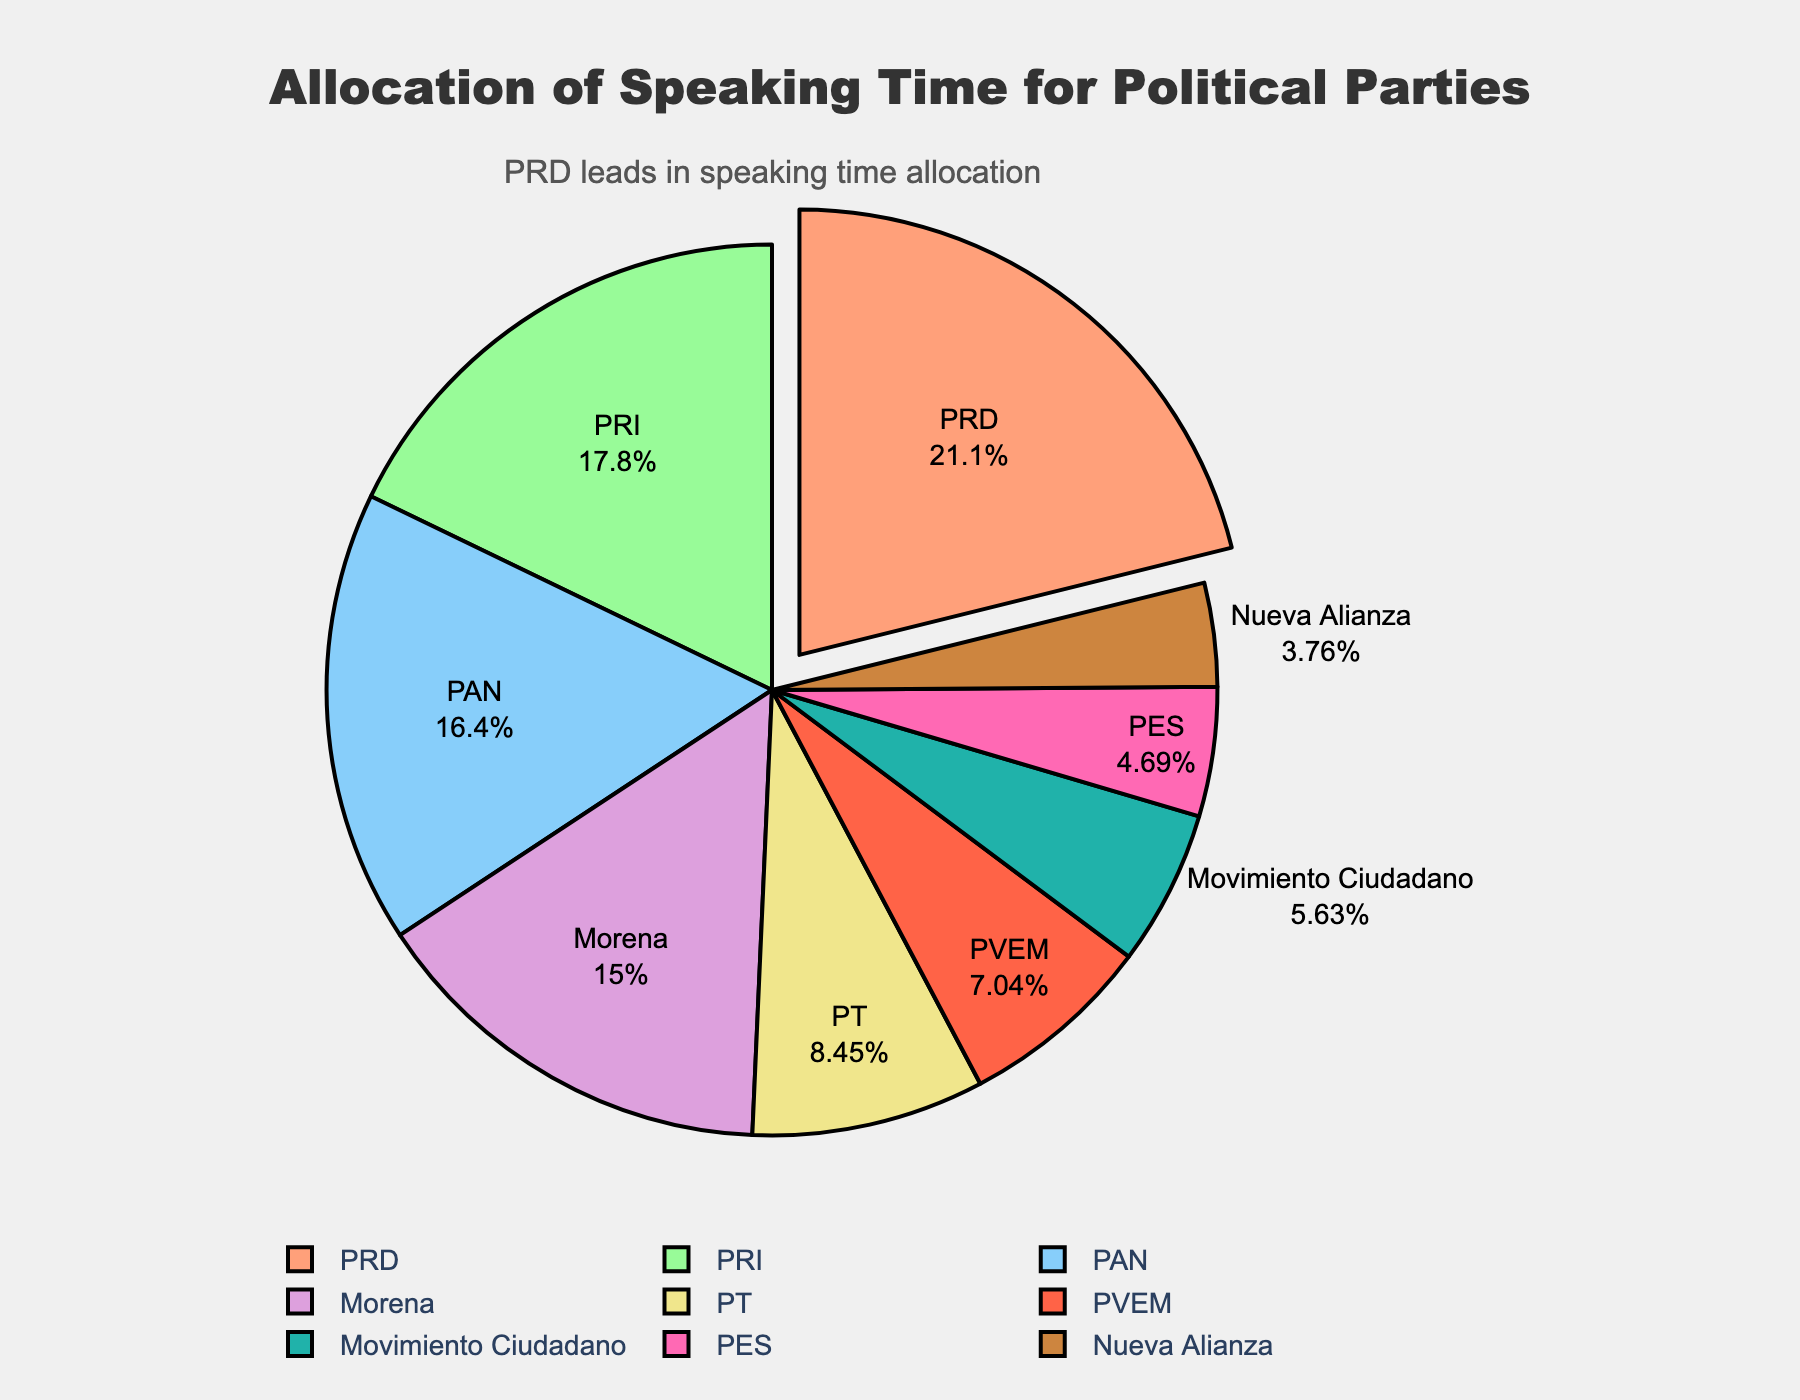What's the percentage of speaking time allocated to the PRD? The figure uses the "label+percent" display, showing the PRD segment explicitly with its percentage. Locate the PRD segment and read the percentage shown.
Answer: 24% Which party has the least speaking time? The pie chart visually represents the segments by size, so the smallest segment represents the party with the least speaking time. Ruta, which is indicated by the smallest segment, has the least speaking time.
Answer: Nueva Alianza What is the total speaking time for PRI and PAN combined? Locate the PRI and PAN segments in the pie chart. The speaking times are listed as 38 minutes for PRI and 35 minutes for PAN. Add these values together: 38 + 35 = 73 minutes.
Answer: 73 minutes How much more speaking time does the PRD have compared to Morena? Find the speaking time values for PRD (45 minutes) and Morena (32 minutes). Subtract Morena’s speaking time from PRD’s: 45 - 32 = 13 minutes.
Answer: 13 minutes Which parties together account for less than 20% of the speaking time each? The pie chart shows the percentage for each party’s speaking time. Identify the segments with percentages less than 20%: PT, PVEM, Movimiento Ciudadano, PES, and Nueva Alianza.
Answer: PT, PVEM, Movimiento Ciudadano, PES, Nueva Alianza Which party has more speaking time, PVEM or PT? By locating the PVEM and PT segments, you can compare their sizes and corresponding values. PT has 18 minutes, and PVEM has 15 minutes; thus, PT has more speaking time.
Answer: PT What is the average speaking time of PRD, PAN, and PRI? The speaking times are 45 minutes (PRD), 35 minutes (PAN), and 38 minutes (PRI). Calculate the average: (45 + 35 + 38) / 3 = 118 / 3 ≈ 39.33 minutes.
Answer: ≈ 39.33 minutes Which party has exactly half the speaking time of PRD? PRD has 45 minutes of speaking time. Look for a segment representing half of that, 22.5 minutes. None match precisely, but PT’s 18 minutes is the closest approximation.
Answer: None What's the difference in speaking time between MOVimiento Ciudadano and PES? Locate the segments and their values, 12 minutes for Movimiento Ciudadano and 10 minutes for PES. Subtract the smaller value from the larger one: 12 - 10 = 2 minutes.
Answer: 2 minutes 